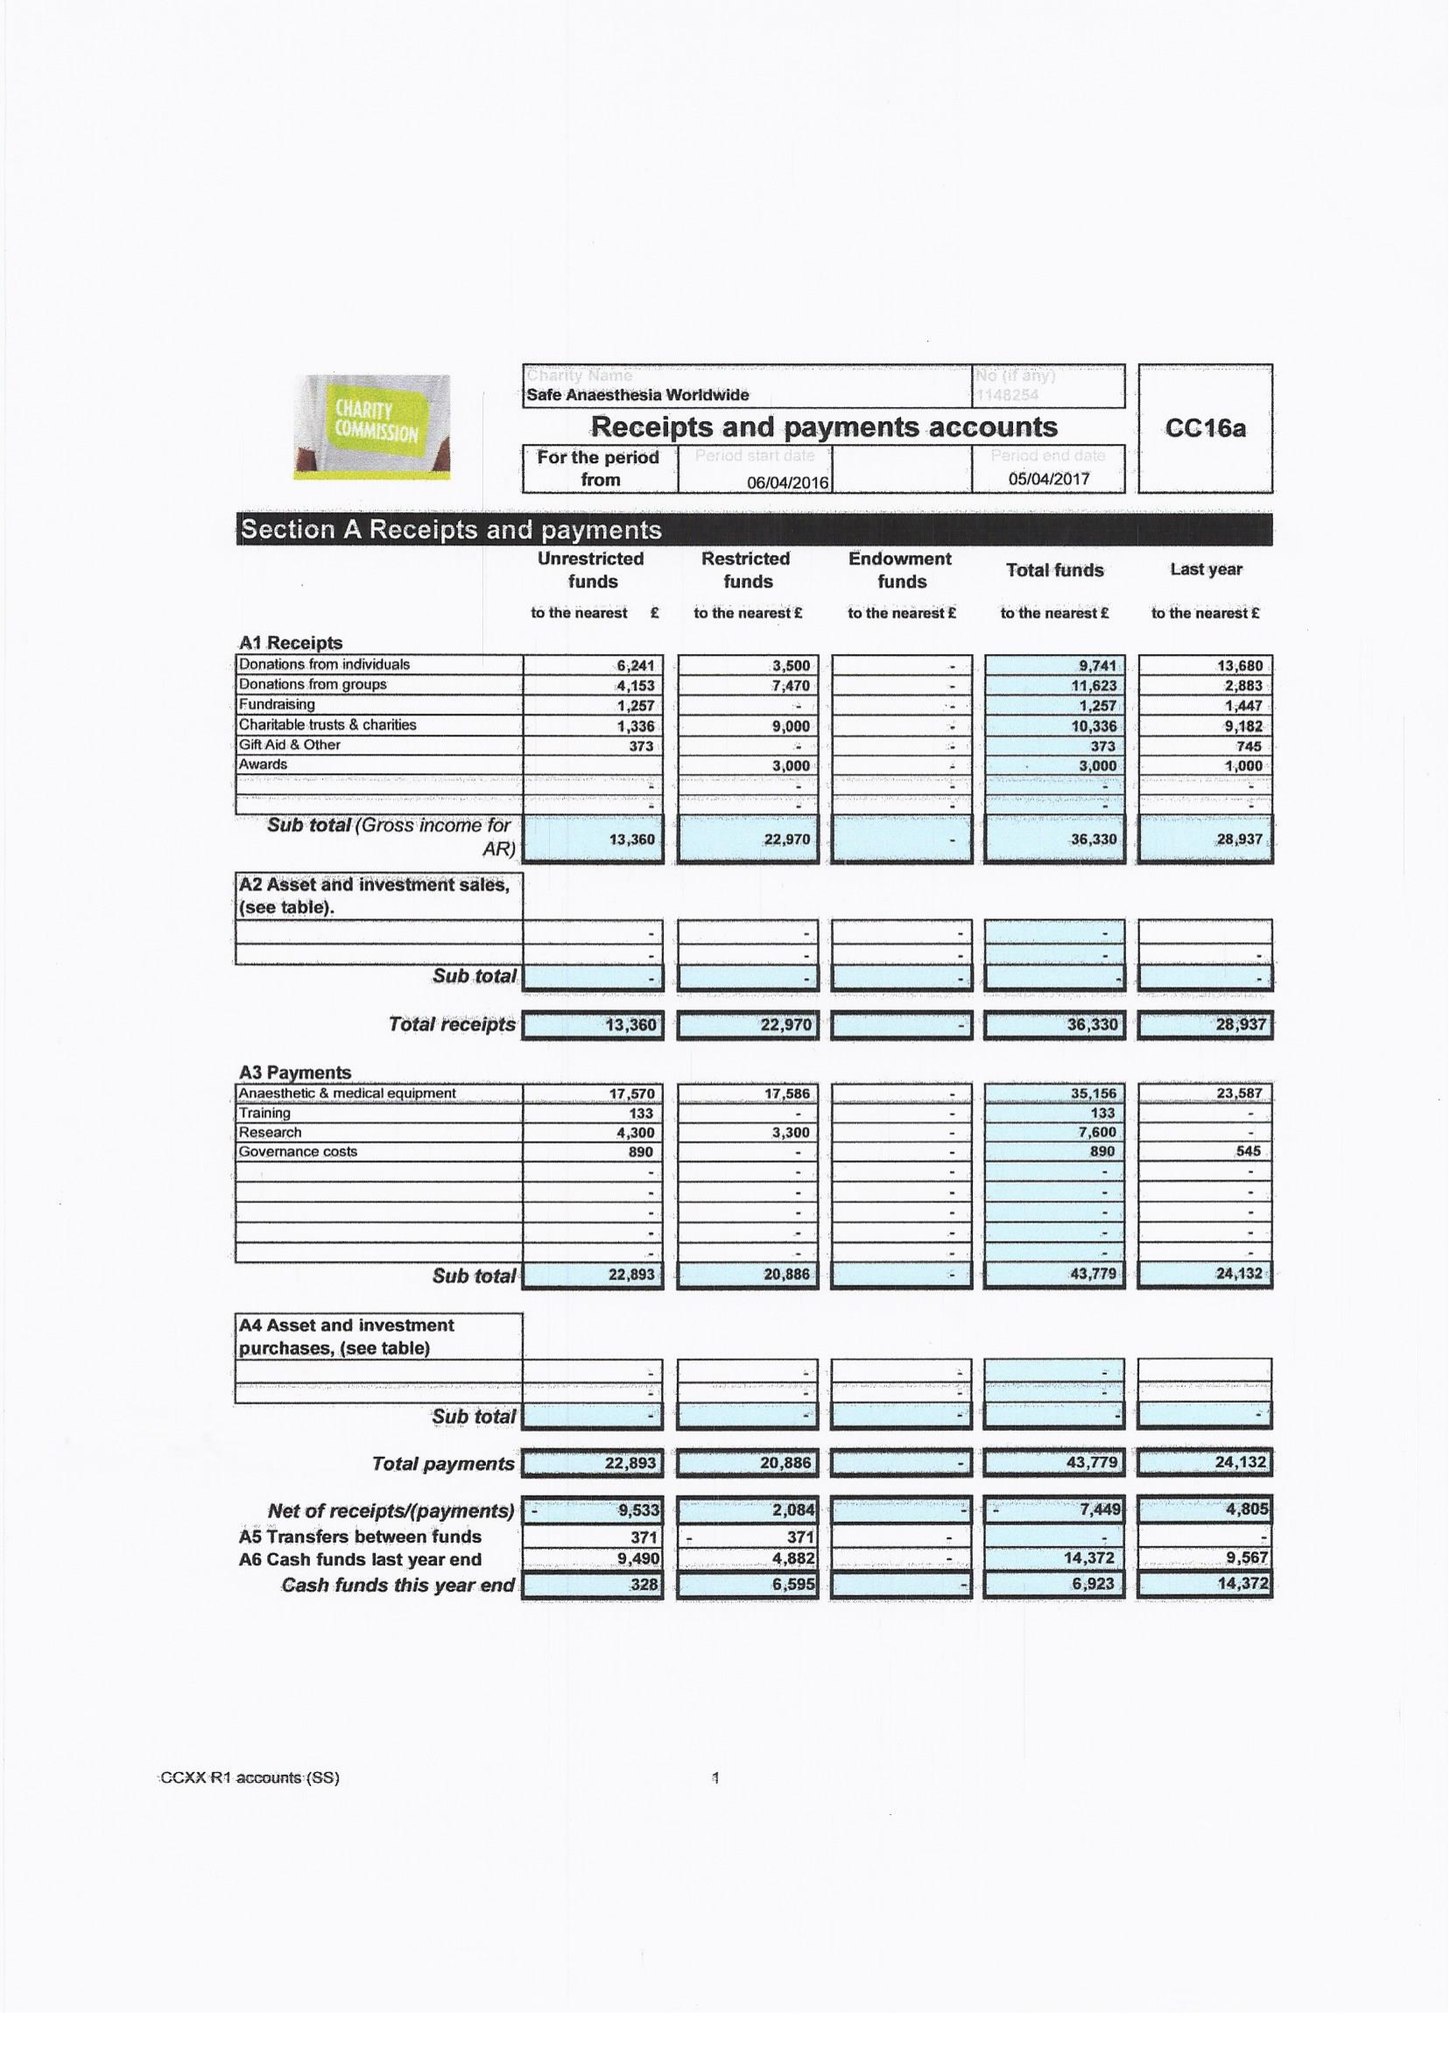What is the value for the spending_annually_in_british_pounds?
Answer the question using a single word or phrase. 43779.00 